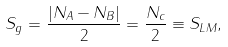Convert formula to latex. <formula><loc_0><loc_0><loc_500><loc_500>S _ { g } = \frac { | N _ { A } - N _ { B } | } { 2 } = \frac { N _ { c } } { 2 } \equiv S _ { L M } ,</formula> 